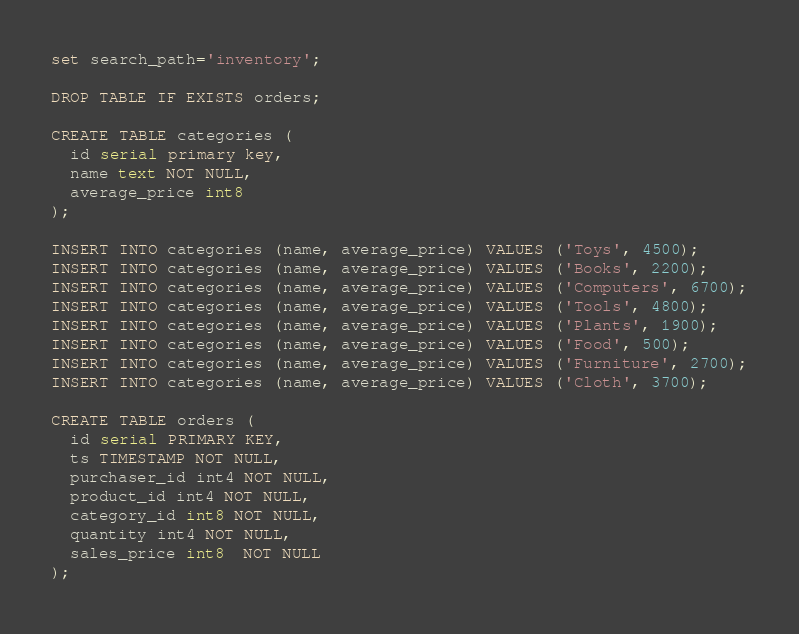<code> <loc_0><loc_0><loc_500><loc_500><_SQL_>
set search_path='inventory';

DROP TABLE IF EXISTS orders;

CREATE TABLE categories (
  id serial primary key,
  name text NOT NULL,
  average_price int8
);

INSERT INTO categories (name, average_price) VALUES ('Toys', 4500);
INSERT INTO categories (name, average_price) VALUES ('Books', 2200);
INSERT INTO categories (name, average_price) VALUES ('Computers', 6700);
INSERT INTO categories (name, average_price) VALUES ('Tools', 4800);
INSERT INTO categories (name, average_price) VALUES ('Plants', 1900);
INSERT INTO categories (name, average_price) VALUES ('Food', 500);
INSERT INTO categories (name, average_price) VALUES ('Furniture', 2700);
INSERT INTO categories (name, average_price) VALUES ('Cloth', 3700);

CREATE TABLE orders (
  id serial PRIMARY KEY,
  ts TIMESTAMP NOT NULL,
  purchaser_id int4 NOT NULL,
  product_id int4 NOT NULL,
  category_id int8 NOT NULL,
  quantity int4 NOT NULL,
  sales_price int8  NOT NULL
);
</code> 